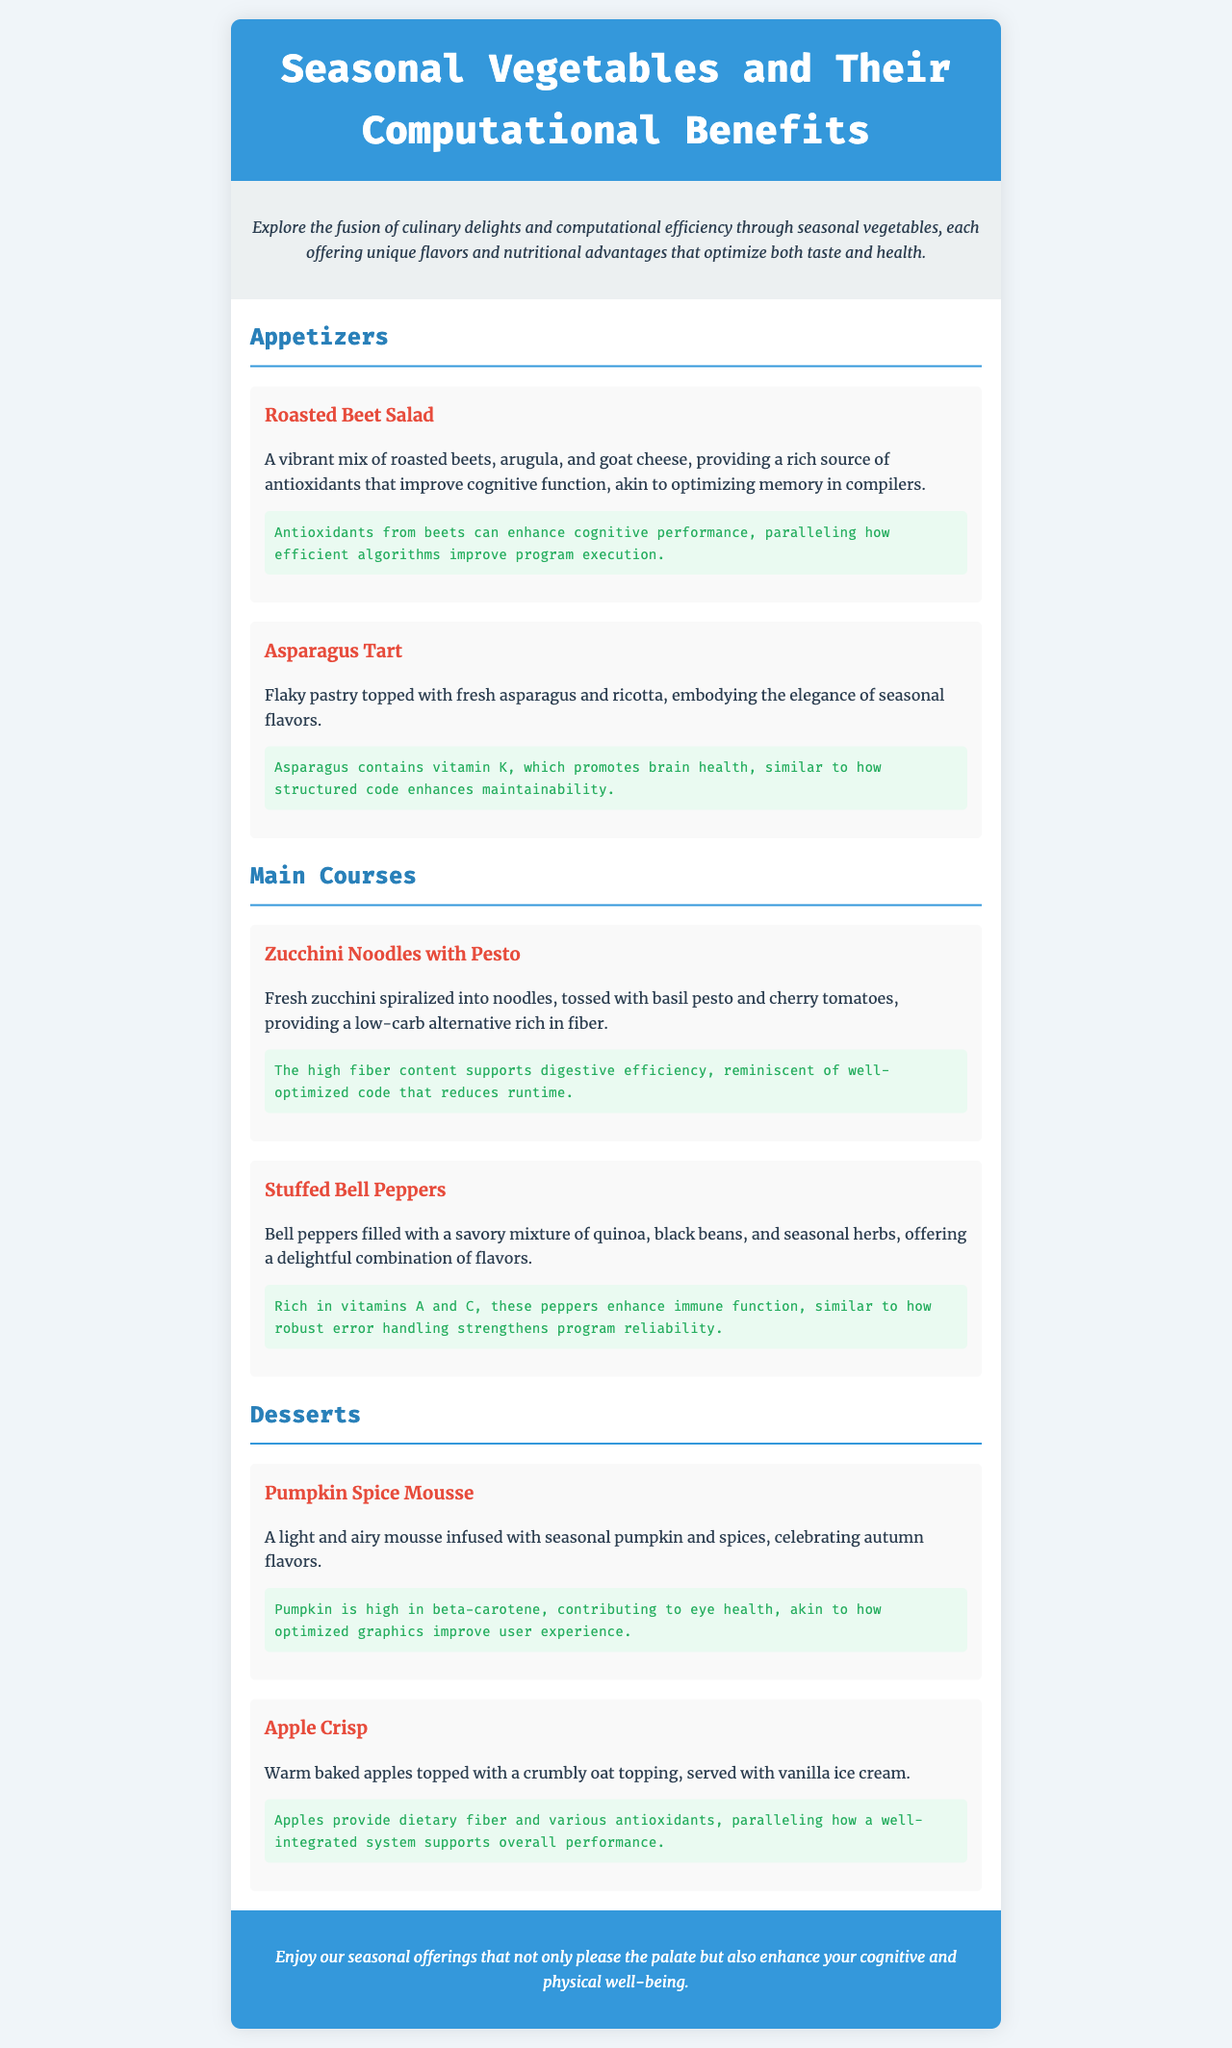What is the title of the document? The title of the document is stated in the head section of the HTML as "Seasonal Vegetables and Their Computational Benefits".
Answer: Seasonal Vegetables and Their Computational Benefits What vegetable is featured in the Roasted Beet Salad? The Roasted Beet Salad prominently features beets as indicated in the description.
Answer: Beets What is the main ingredient in the Zucchini Noodles with Pesto? The main ingredient for this dish is mentioned as fresh zucchini, which is specified in the description.
Answer: Zucchini How many appetizers are listed in the document? The document lists two appetizers under the Appetizers section: Roasted Beet Salad and Asparagus Tart.
Answer: 2 Which dish contains a mixture of quinoa and black beans? The dish filled with a savory mixture of quinoa and black beans is specified as Stuffed Bell Peppers in the Main Courses section.
Answer: Stuffed Bell Peppers What benefit do antioxidants from beets provide? Antioxidants from beets are said to improve cognitive function, as stated in the computational benefit description.
Answer: Improve cognitive function What is the closing remark theme? The closing remark emphasizes the enhancement of cognitive and physical well-being through seasonal offerings.
Answer: Cognitive and physical well-being Which dish celebrates autumn flavors? The dish that celebrates autumn flavors is described as Pumpkin Spice Mousse in the Desserts section.
Answer: Pumpkin Spice Mousse What vitamin does asparagus contain that promotes brain health? The document mentions that asparagus contains vitamin K, which promotes brain health.
Answer: Vitamin K 